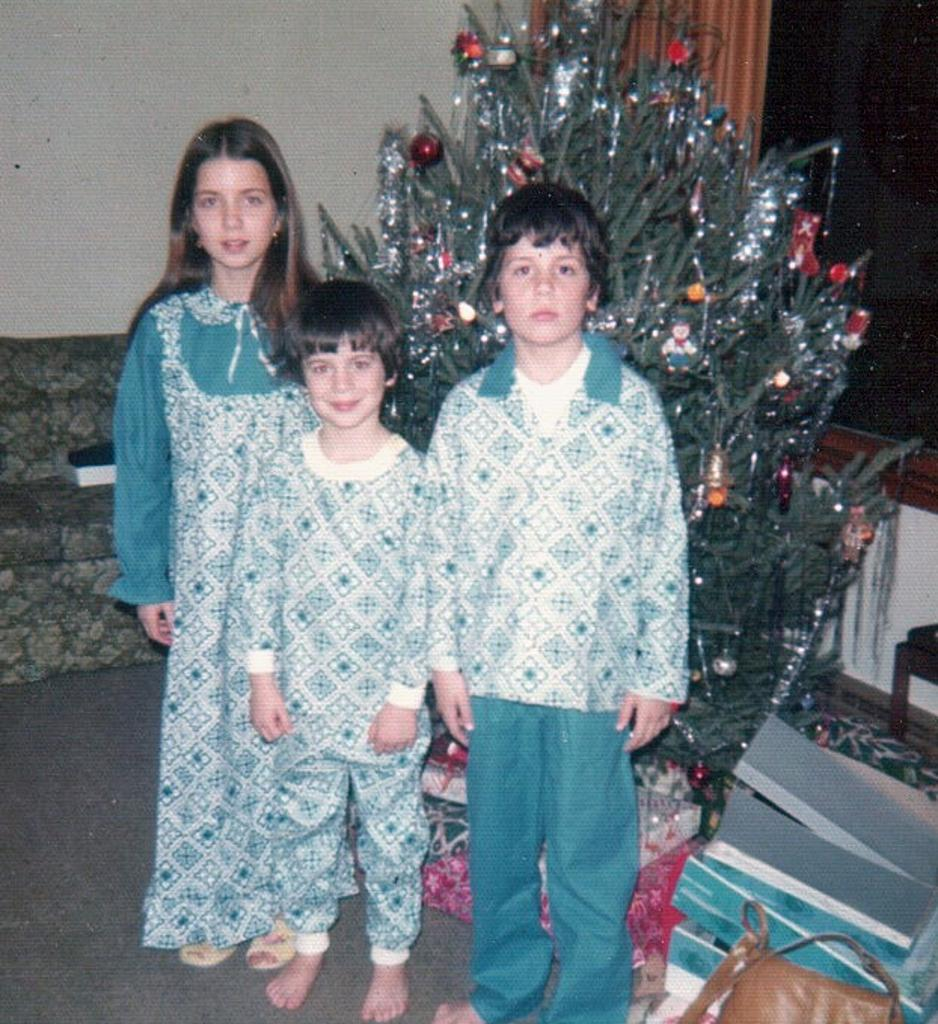What is the main subject of the image? The main subject of the image is a group of children. What are the children doing in the image? The children are standing in the image. What natural element can be seen in the image? There is a tree in the image. What type of furniture is present in the image? There is a sofa on a carpet in the image. What architectural feature is visible in the image? There is a wall in the image. What type of advertisement can be seen on the wall in the image? There is no advertisement present on the wall in the image. How does the crook feel about his actions in the image? There is no crook or any indication of criminal activity in the image. 